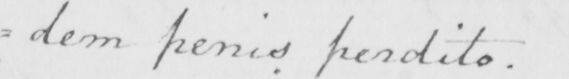Please transcribe the handwritten text in this image. =dem penis perdito . 